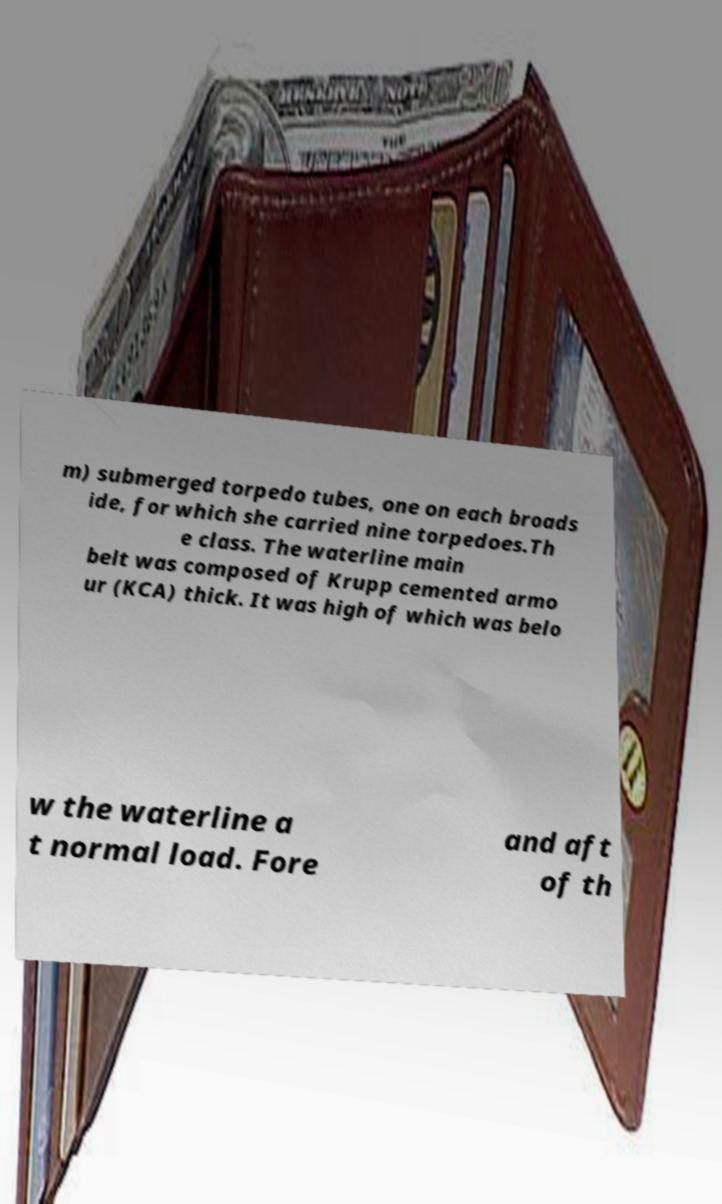Could you assist in decoding the text presented in this image and type it out clearly? m) submerged torpedo tubes, one on each broads ide, for which she carried nine torpedoes.Th e class. The waterline main belt was composed of Krupp cemented armo ur (KCA) thick. It was high of which was belo w the waterline a t normal load. Fore and aft of th 